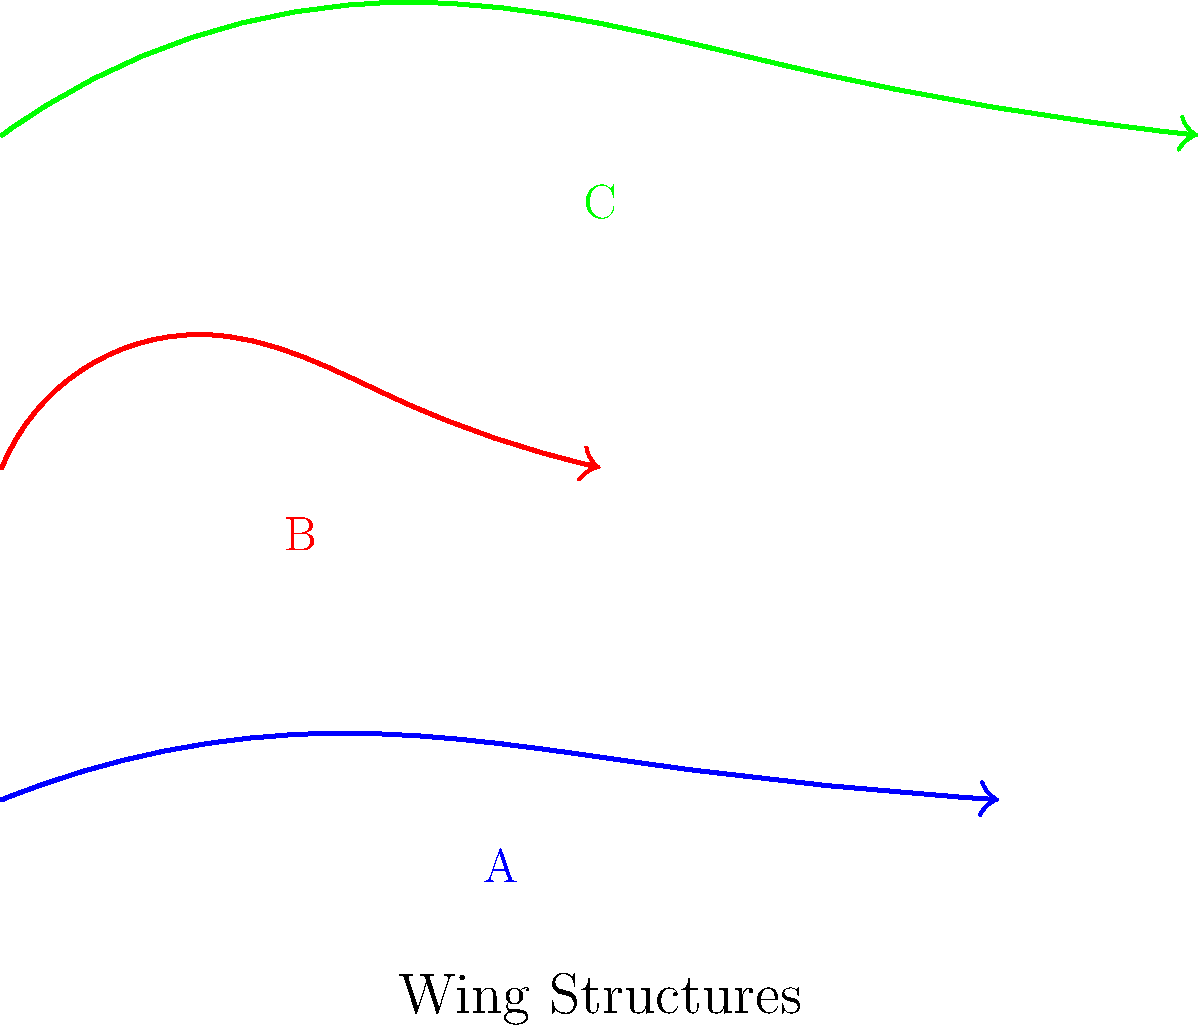Based on the anatomical illustrations of wing structures shown above, which bird species is most likely represented by Wing B, and how does its structure relate to its unique flight capabilities? To answer this question, let's analyze the wing structures and their implications:

1. Wing A (blue): Long and narrow, typical of seabirds like albatrosses, adapted for soaring and gliding over long distances.

2. Wing B (red): Short and stubby, with a distinctive curved shape. This is characteristic of hummingbirds, adapted for hovering and rapid maneuverability.

3. Wing C (green): Broad and long, typical of large birds of prey like eagles, adapted for soaring and powerful flight.

Wing B's structure is unique among the three:
1. Short length: Allows for rapid wing beats.
2. High curvature: Provides lift at low speeds.
3. Stubby shape: Enables quick changes in direction.

These features are hallmarks of hummingbird wings, which allow them to:
a) Hover in place
b) Fly backwards
c) Make rapid directional changes
d) Achieve incredibly high wing beat frequencies (up to 80 beats per second)

The short, curved structure of Wing B maximizes lift generation at low speeds, crucial for hovering. It also minimizes inertia, allowing for rapid acceleration and deceleration, essential for the hummingbird's unique flight capabilities.
Answer: Hummingbird; short, curved structure enables hovering and rapid directional changes. 